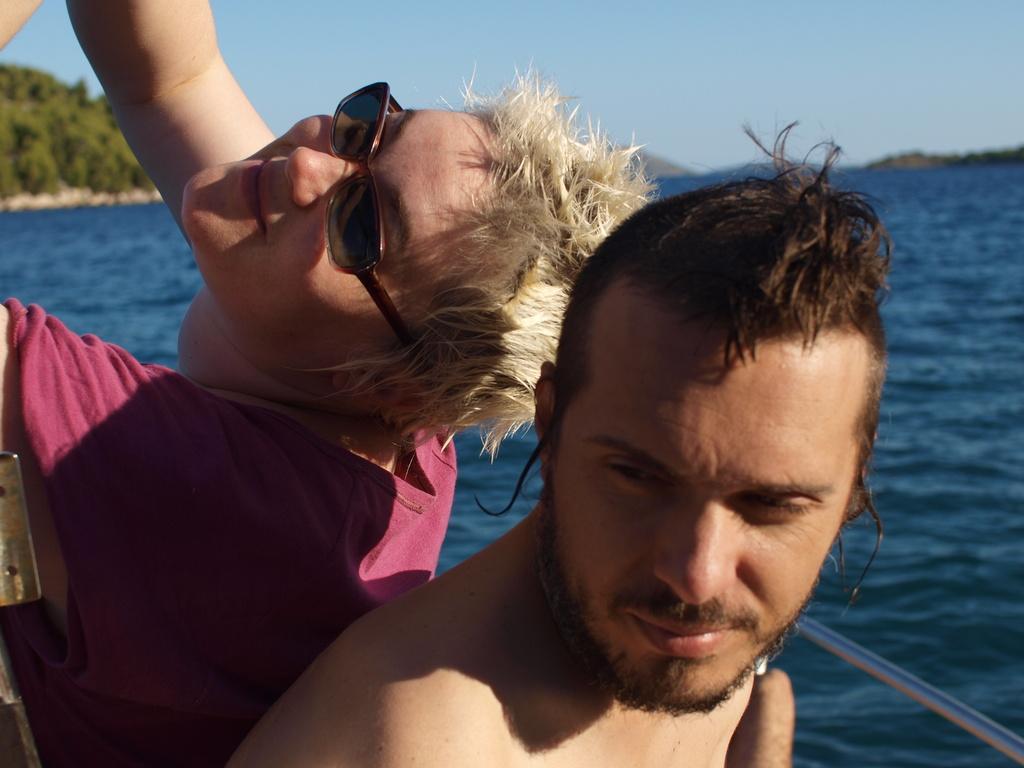Could you give a brief overview of what you see in this image? In this image we can see persons on boat. In the background we can see hills, water and sky. 